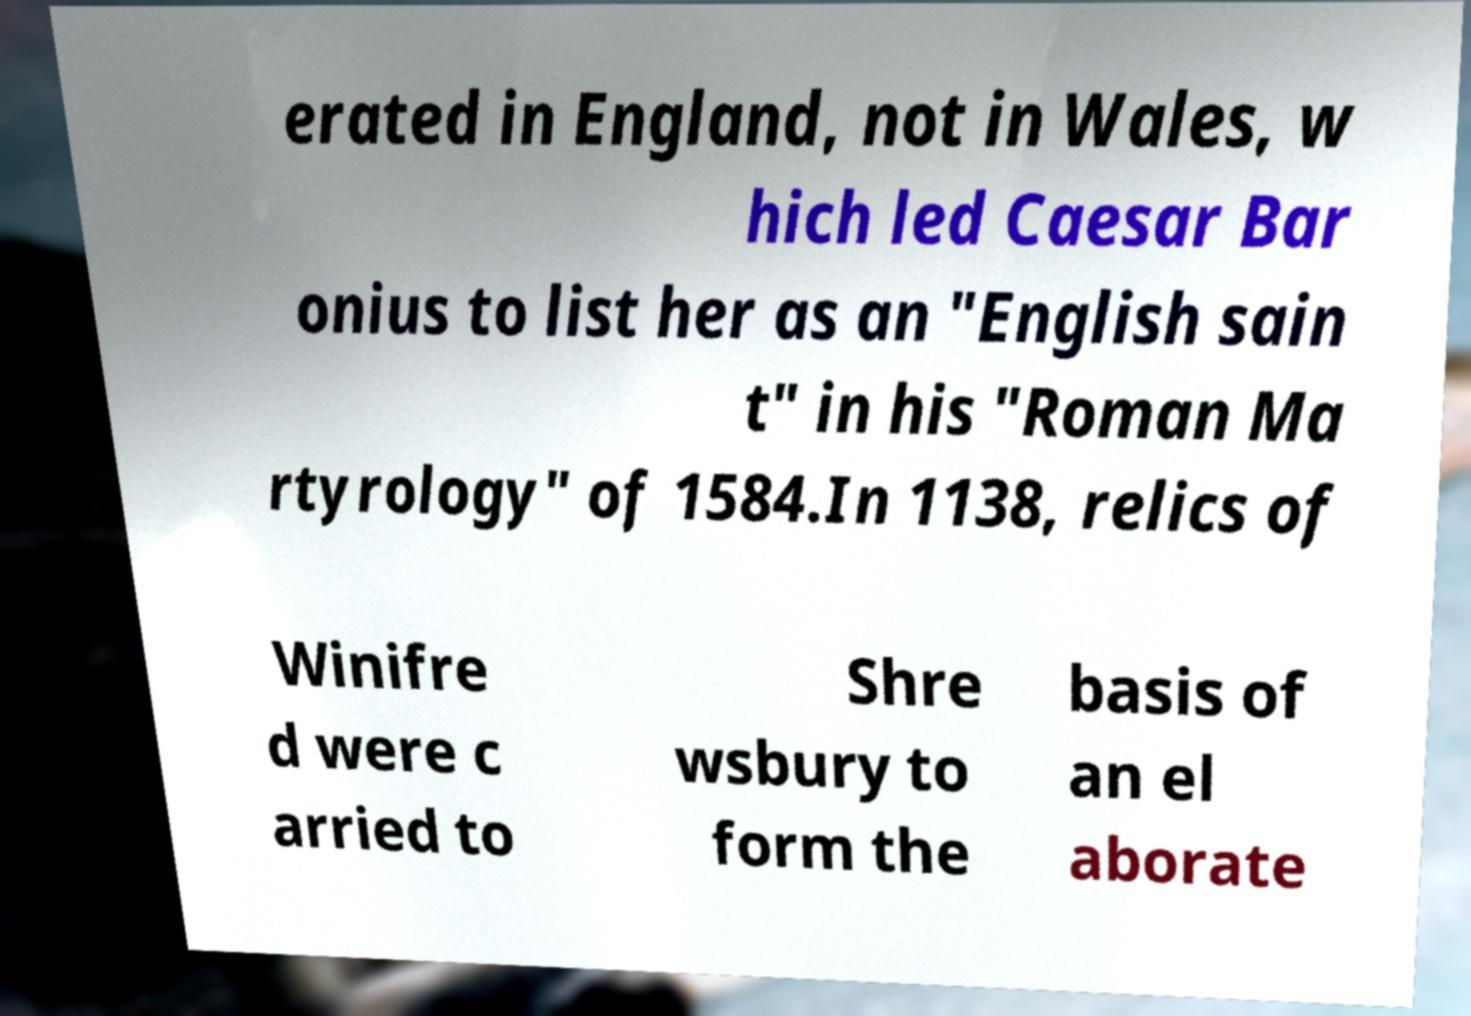Please read and relay the text visible in this image. What does it say? erated in England, not in Wales, w hich led Caesar Bar onius to list her as an "English sain t" in his "Roman Ma rtyrology" of 1584.In 1138, relics of Winifre d were c arried to Shre wsbury to form the basis of an el aborate 